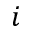<formula> <loc_0><loc_0><loc_500><loc_500>i</formula> 